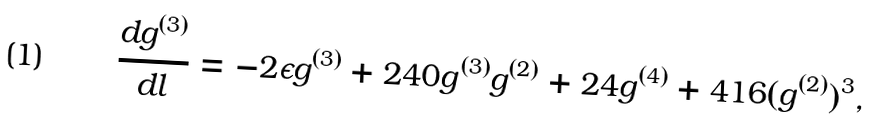<formula> <loc_0><loc_0><loc_500><loc_500>\frac { d g ^ { ( 3 ) } } { d l } = - 2 \epsilon g ^ { ( 3 ) } + 2 4 0 g ^ { ( 3 ) } g ^ { ( 2 ) } + 2 4 g ^ { ( 4 ) } + 4 1 6 ( g ^ { ( 2 ) } ) ^ { 3 } ,</formula> 